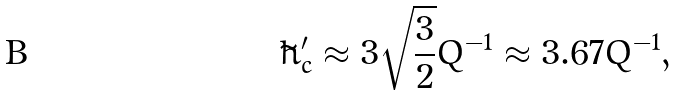Convert formula to latex. <formula><loc_0><loc_0><loc_500><loc_500>\tilde { h } ^ { \prime } _ { c } \approx 3 \sqrt { \frac { 3 } { 2 } } Q ^ { - 1 } \approx 3 . 6 7 Q ^ { - 1 } ,</formula> 